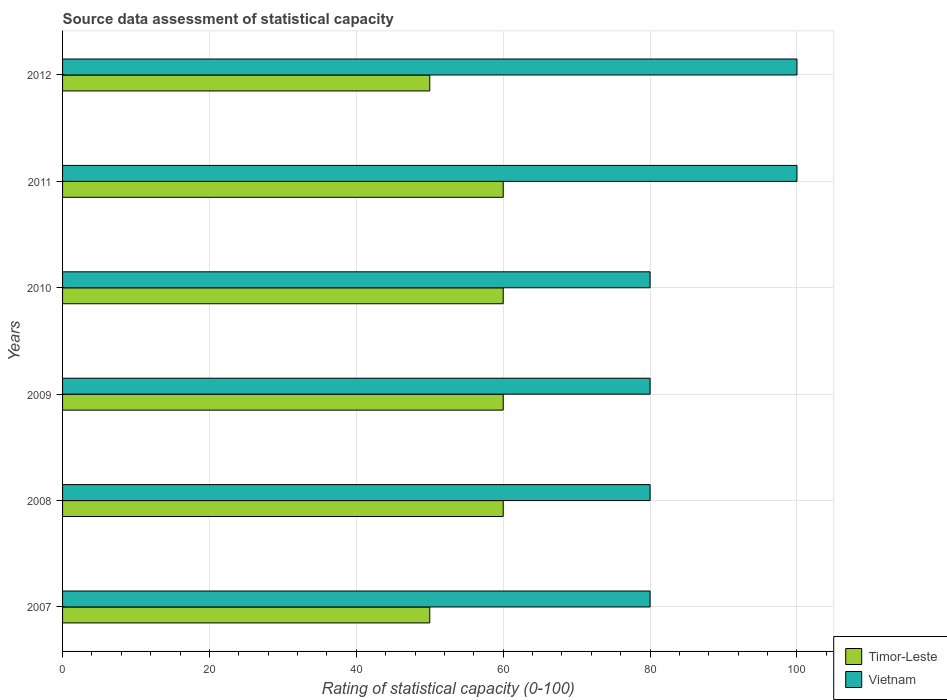How many bars are there on the 1st tick from the top?
Your answer should be very brief. 2. What is the label of the 1st group of bars from the top?
Your answer should be compact. 2012. In how many cases, is the number of bars for a given year not equal to the number of legend labels?
Your answer should be compact. 0. What is the rating of statistical capacity in Timor-Leste in 2007?
Offer a very short reply. 50. Across all years, what is the maximum rating of statistical capacity in Vietnam?
Your answer should be compact. 100. Across all years, what is the minimum rating of statistical capacity in Vietnam?
Offer a very short reply. 80. In which year was the rating of statistical capacity in Vietnam maximum?
Offer a very short reply. 2011. In which year was the rating of statistical capacity in Vietnam minimum?
Ensure brevity in your answer.  2007. What is the total rating of statistical capacity in Timor-Leste in the graph?
Your answer should be compact. 340. What is the difference between the rating of statistical capacity in Timor-Leste in 2011 and that in 2012?
Make the answer very short. 10. What is the difference between the rating of statistical capacity in Vietnam in 2010 and the rating of statistical capacity in Timor-Leste in 2008?
Your response must be concise. 20. What is the average rating of statistical capacity in Timor-Leste per year?
Provide a succinct answer. 56.67. What is the ratio of the rating of statistical capacity in Timor-Leste in 2007 to that in 2008?
Your answer should be compact. 0.83. What is the difference between the highest and the second highest rating of statistical capacity in Timor-Leste?
Your response must be concise. 0. What is the difference between the highest and the lowest rating of statistical capacity in Timor-Leste?
Ensure brevity in your answer.  10. Is the sum of the rating of statistical capacity in Timor-Leste in 2010 and 2011 greater than the maximum rating of statistical capacity in Vietnam across all years?
Your answer should be compact. Yes. What does the 2nd bar from the top in 2011 represents?
Your response must be concise. Timor-Leste. What does the 1st bar from the bottom in 2007 represents?
Ensure brevity in your answer.  Timor-Leste. Are all the bars in the graph horizontal?
Ensure brevity in your answer.  Yes. How many years are there in the graph?
Provide a succinct answer. 6. Are the values on the major ticks of X-axis written in scientific E-notation?
Offer a terse response. No. Does the graph contain grids?
Your response must be concise. Yes. Where does the legend appear in the graph?
Your response must be concise. Bottom right. How many legend labels are there?
Offer a terse response. 2. What is the title of the graph?
Give a very brief answer. Source data assessment of statistical capacity. Does "Bahrain" appear as one of the legend labels in the graph?
Keep it short and to the point. No. What is the label or title of the X-axis?
Offer a very short reply. Rating of statistical capacity (0-100). What is the label or title of the Y-axis?
Offer a very short reply. Years. What is the Rating of statistical capacity (0-100) of Vietnam in 2008?
Your answer should be compact. 80. What is the Rating of statistical capacity (0-100) of Timor-Leste in 2009?
Provide a short and direct response. 60. What is the Rating of statistical capacity (0-100) in Timor-Leste in 2010?
Your answer should be very brief. 60. What is the Rating of statistical capacity (0-100) in Vietnam in 2010?
Your answer should be compact. 80. What is the Rating of statistical capacity (0-100) in Vietnam in 2011?
Your answer should be very brief. 100. What is the Rating of statistical capacity (0-100) in Timor-Leste in 2012?
Keep it short and to the point. 50. What is the Rating of statistical capacity (0-100) in Vietnam in 2012?
Your response must be concise. 100. Across all years, what is the maximum Rating of statistical capacity (0-100) of Timor-Leste?
Keep it short and to the point. 60. Across all years, what is the minimum Rating of statistical capacity (0-100) of Timor-Leste?
Provide a succinct answer. 50. What is the total Rating of statistical capacity (0-100) of Timor-Leste in the graph?
Ensure brevity in your answer.  340. What is the total Rating of statistical capacity (0-100) of Vietnam in the graph?
Keep it short and to the point. 520. What is the difference between the Rating of statistical capacity (0-100) in Timor-Leste in 2007 and that in 2008?
Make the answer very short. -10. What is the difference between the Rating of statistical capacity (0-100) of Vietnam in 2007 and that in 2008?
Offer a terse response. 0. What is the difference between the Rating of statistical capacity (0-100) of Timor-Leste in 2007 and that in 2009?
Make the answer very short. -10. What is the difference between the Rating of statistical capacity (0-100) of Timor-Leste in 2007 and that in 2010?
Make the answer very short. -10. What is the difference between the Rating of statistical capacity (0-100) in Vietnam in 2007 and that in 2010?
Ensure brevity in your answer.  0. What is the difference between the Rating of statistical capacity (0-100) of Timor-Leste in 2007 and that in 2011?
Keep it short and to the point. -10. What is the difference between the Rating of statistical capacity (0-100) in Vietnam in 2008 and that in 2009?
Your answer should be very brief. 0. What is the difference between the Rating of statistical capacity (0-100) in Timor-Leste in 2008 and that in 2010?
Provide a short and direct response. 0. What is the difference between the Rating of statistical capacity (0-100) in Timor-Leste in 2008 and that in 2011?
Your answer should be very brief. 0. What is the difference between the Rating of statistical capacity (0-100) in Vietnam in 2008 and that in 2011?
Keep it short and to the point. -20. What is the difference between the Rating of statistical capacity (0-100) of Timor-Leste in 2008 and that in 2012?
Give a very brief answer. 10. What is the difference between the Rating of statistical capacity (0-100) of Timor-Leste in 2009 and that in 2010?
Offer a very short reply. 0. What is the difference between the Rating of statistical capacity (0-100) of Vietnam in 2009 and that in 2011?
Make the answer very short. -20. What is the difference between the Rating of statistical capacity (0-100) of Timor-Leste in 2009 and that in 2012?
Make the answer very short. 10. What is the difference between the Rating of statistical capacity (0-100) in Vietnam in 2009 and that in 2012?
Give a very brief answer. -20. What is the difference between the Rating of statistical capacity (0-100) in Timor-Leste in 2010 and that in 2011?
Provide a succinct answer. 0. What is the difference between the Rating of statistical capacity (0-100) in Vietnam in 2010 and that in 2011?
Offer a very short reply. -20. What is the difference between the Rating of statistical capacity (0-100) of Timor-Leste in 2010 and that in 2012?
Offer a very short reply. 10. What is the difference between the Rating of statistical capacity (0-100) of Vietnam in 2010 and that in 2012?
Offer a very short reply. -20. What is the difference between the Rating of statistical capacity (0-100) in Timor-Leste in 2007 and the Rating of statistical capacity (0-100) in Vietnam in 2010?
Provide a short and direct response. -30. What is the difference between the Rating of statistical capacity (0-100) of Timor-Leste in 2008 and the Rating of statistical capacity (0-100) of Vietnam in 2011?
Offer a very short reply. -40. What is the difference between the Rating of statistical capacity (0-100) of Timor-Leste in 2008 and the Rating of statistical capacity (0-100) of Vietnam in 2012?
Offer a very short reply. -40. What is the difference between the Rating of statistical capacity (0-100) in Timor-Leste in 2009 and the Rating of statistical capacity (0-100) in Vietnam in 2012?
Ensure brevity in your answer.  -40. What is the difference between the Rating of statistical capacity (0-100) in Timor-Leste in 2010 and the Rating of statistical capacity (0-100) in Vietnam in 2011?
Keep it short and to the point. -40. What is the average Rating of statistical capacity (0-100) of Timor-Leste per year?
Give a very brief answer. 56.67. What is the average Rating of statistical capacity (0-100) in Vietnam per year?
Provide a short and direct response. 86.67. In the year 2007, what is the difference between the Rating of statistical capacity (0-100) of Timor-Leste and Rating of statistical capacity (0-100) of Vietnam?
Keep it short and to the point. -30. In the year 2010, what is the difference between the Rating of statistical capacity (0-100) of Timor-Leste and Rating of statistical capacity (0-100) of Vietnam?
Your answer should be very brief. -20. In the year 2011, what is the difference between the Rating of statistical capacity (0-100) in Timor-Leste and Rating of statistical capacity (0-100) in Vietnam?
Ensure brevity in your answer.  -40. In the year 2012, what is the difference between the Rating of statistical capacity (0-100) of Timor-Leste and Rating of statistical capacity (0-100) of Vietnam?
Give a very brief answer. -50. What is the ratio of the Rating of statistical capacity (0-100) of Timor-Leste in 2007 to that in 2008?
Give a very brief answer. 0.83. What is the ratio of the Rating of statistical capacity (0-100) in Vietnam in 2007 to that in 2008?
Make the answer very short. 1. What is the ratio of the Rating of statistical capacity (0-100) in Vietnam in 2007 to that in 2009?
Offer a very short reply. 1. What is the ratio of the Rating of statistical capacity (0-100) of Timor-Leste in 2007 to that in 2010?
Ensure brevity in your answer.  0.83. What is the ratio of the Rating of statistical capacity (0-100) in Timor-Leste in 2007 to that in 2011?
Your answer should be compact. 0.83. What is the ratio of the Rating of statistical capacity (0-100) in Timor-Leste in 2008 to that in 2009?
Your answer should be compact. 1. What is the ratio of the Rating of statistical capacity (0-100) in Vietnam in 2008 to that in 2009?
Keep it short and to the point. 1. What is the ratio of the Rating of statistical capacity (0-100) in Vietnam in 2008 to that in 2010?
Your answer should be compact. 1. What is the ratio of the Rating of statistical capacity (0-100) in Timor-Leste in 2008 to that in 2011?
Your answer should be compact. 1. What is the ratio of the Rating of statistical capacity (0-100) of Timor-Leste in 2009 to that in 2011?
Provide a succinct answer. 1. What is the ratio of the Rating of statistical capacity (0-100) of Vietnam in 2009 to that in 2011?
Keep it short and to the point. 0.8. What is the ratio of the Rating of statistical capacity (0-100) of Vietnam in 2009 to that in 2012?
Ensure brevity in your answer.  0.8. What is the ratio of the Rating of statistical capacity (0-100) of Vietnam in 2010 to that in 2011?
Offer a terse response. 0.8. What is the ratio of the Rating of statistical capacity (0-100) of Vietnam in 2011 to that in 2012?
Your answer should be compact. 1. What is the difference between the highest and the second highest Rating of statistical capacity (0-100) of Vietnam?
Your answer should be very brief. 0. What is the difference between the highest and the lowest Rating of statistical capacity (0-100) in Vietnam?
Provide a short and direct response. 20. 